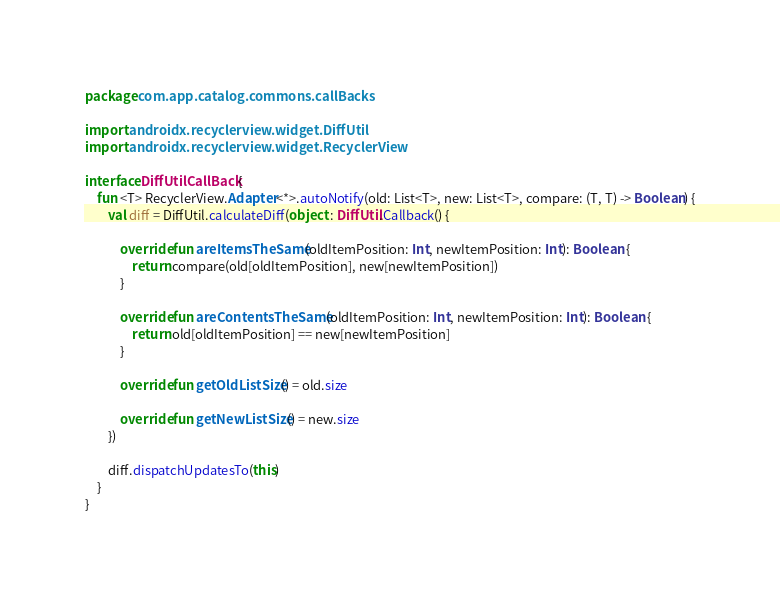<code> <loc_0><loc_0><loc_500><loc_500><_Kotlin_>package com.app.catalog.commons.callBacks

import androidx.recyclerview.widget.DiffUtil
import androidx.recyclerview.widget.RecyclerView

interface DiffUtilCallBack {
    fun <T> RecyclerView.Adapter<*>.autoNotify(old: List<T>, new: List<T>, compare: (T, T) -> Boolean) {
        val diff = DiffUtil.calculateDiff(object : DiffUtil.Callback() {

            override fun areItemsTheSame(oldItemPosition: Int, newItemPosition: Int): Boolean {
                return compare(old[oldItemPosition], new[newItemPosition])
            }

            override fun areContentsTheSame(oldItemPosition: Int, newItemPosition: Int): Boolean {
                return old[oldItemPosition] == new[newItemPosition]
            }

            override fun getOldListSize() = old.size

            override fun getNewListSize() = new.size
        })

        diff.dispatchUpdatesTo(this)
    }
}</code> 